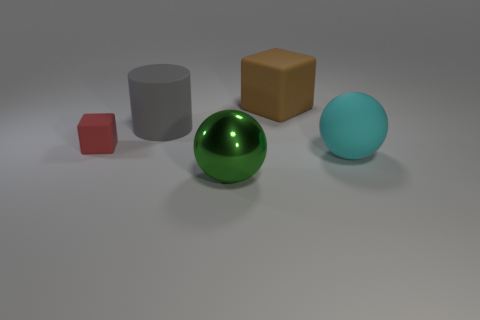Add 4 large green metallic things. How many objects exist? 9 Subtract 1 balls. How many balls are left? 1 Subtract all brown cubes. How many cubes are left? 1 Subtract all spheres. How many objects are left? 3 Add 4 tiny rubber objects. How many tiny rubber objects are left? 5 Add 1 big yellow metal cylinders. How many big yellow metal cylinders exist? 1 Subtract 0 blue spheres. How many objects are left? 5 Subtract all blue spheres. Subtract all blue cubes. How many spheres are left? 2 Subtract all blue blocks. How many brown cylinders are left? 0 Subtract all tiny purple cylinders. Subtract all large green metal objects. How many objects are left? 4 